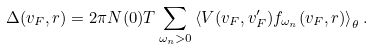Convert formula to latex. <formula><loc_0><loc_0><loc_500><loc_500>\Delta ( { v } _ { F } , { r } ) = 2 \pi N ( 0 ) T \sum _ { \omega _ { n } > 0 } \left < V ( { v } _ { F } , { v } _ { F } ^ { \prime } ) f _ { \omega _ { n } } ( { v } _ { F } , { r } ) \right > _ { \theta } .</formula> 